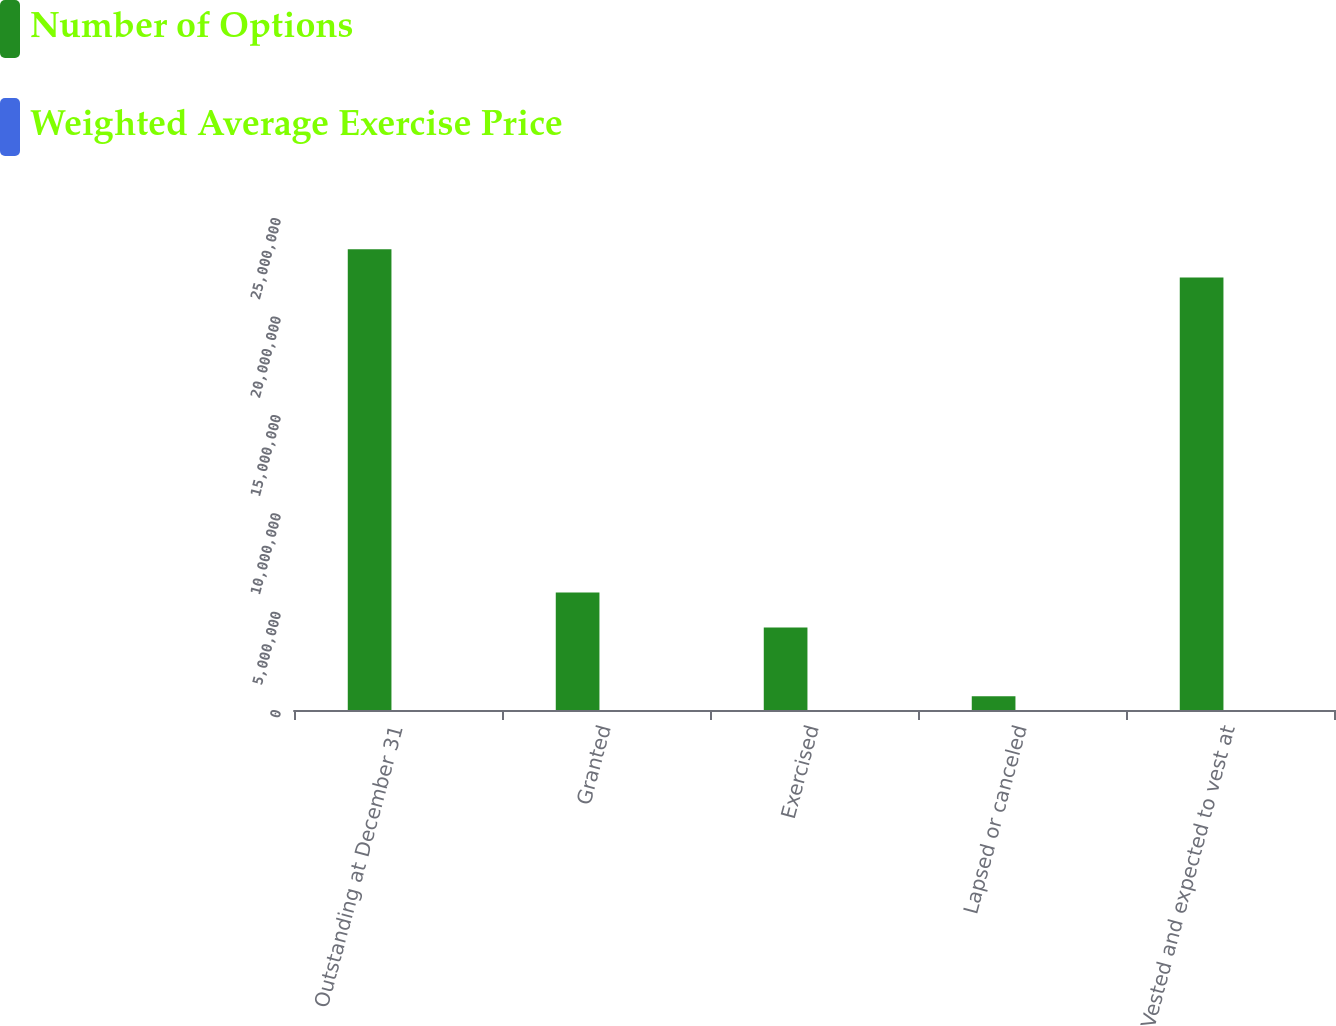Convert chart to OTSL. <chart><loc_0><loc_0><loc_500><loc_500><stacked_bar_chart><ecel><fcel>Outstanding at December 31<fcel>Granted<fcel>Exercised<fcel>Lapsed or canceled<fcel>Vested and expected to vest at<nl><fcel>Number of Options<fcel>2.34093e+07<fcel>5.96726e+06<fcel>4.1903e+06<fcel>703132<fcel>2.19795e+07<nl><fcel>Weighted Average Exercise Price<fcel>94.16<fcel>103.87<fcel>53.4<fcel>84.31<fcel>92.58<nl></chart> 